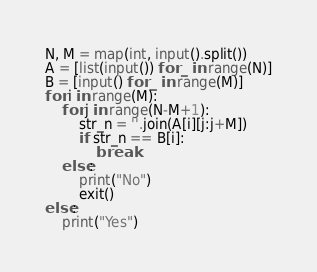Convert code to text. <code><loc_0><loc_0><loc_500><loc_500><_Python_>N, M = map(int, input().split())
A = [list(input()) for _ in range(N)]
B = [input() for _ in range(M)]
for i in range(M):
    for j in range(N-M+1):
        str_n = ''.join(A[i][j:j+M])
        if str_n == B[i]:
            break
    else:
        print("No")
        exit()
else:
    print("Yes")</code> 